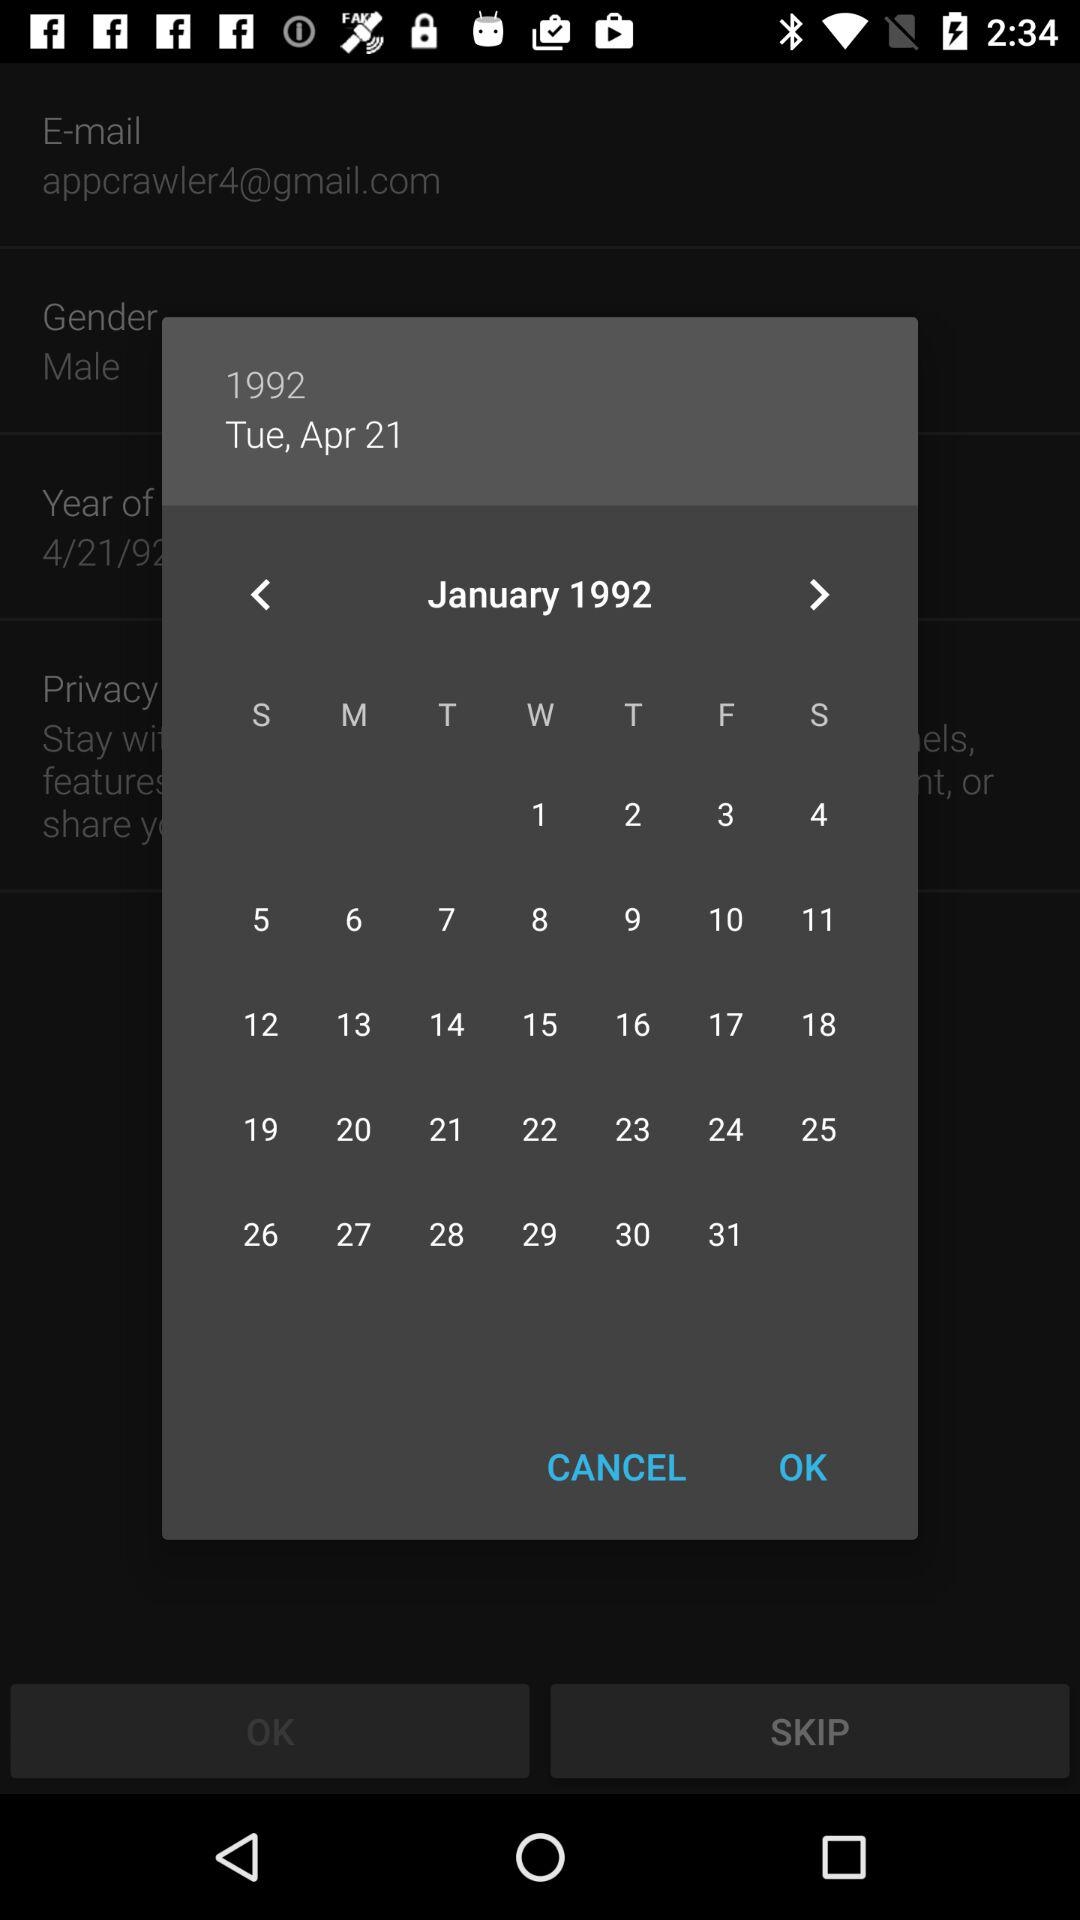Which year is shown in the calendar? The year shown in the calendar is 1992. 